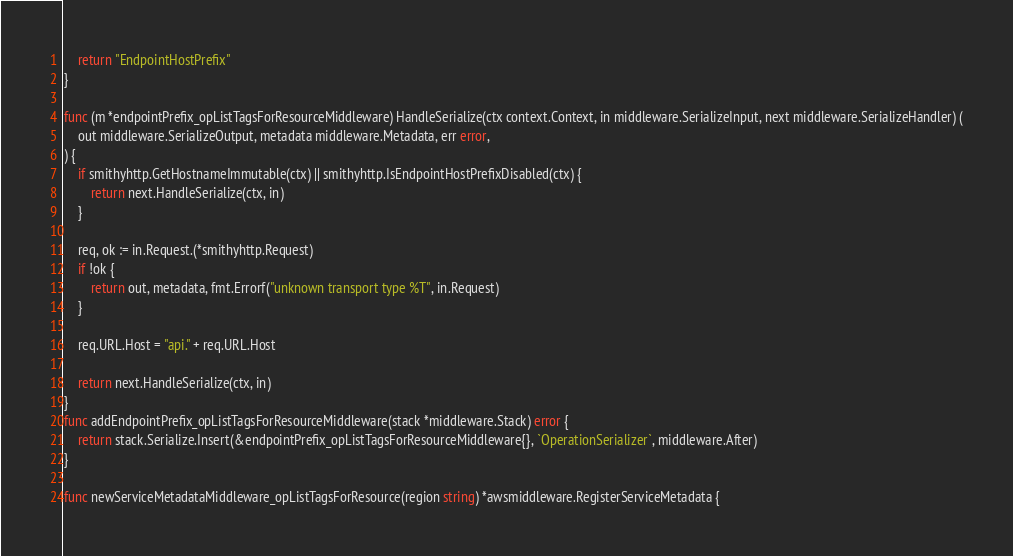<code> <loc_0><loc_0><loc_500><loc_500><_Go_>	return "EndpointHostPrefix"
}

func (m *endpointPrefix_opListTagsForResourceMiddleware) HandleSerialize(ctx context.Context, in middleware.SerializeInput, next middleware.SerializeHandler) (
	out middleware.SerializeOutput, metadata middleware.Metadata, err error,
) {
	if smithyhttp.GetHostnameImmutable(ctx) || smithyhttp.IsEndpointHostPrefixDisabled(ctx) {
		return next.HandleSerialize(ctx, in)
	}

	req, ok := in.Request.(*smithyhttp.Request)
	if !ok {
		return out, metadata, fmt.Errorf("unknown transport type %T", in.Request)
	}

	req.URL.Host = "api." + req.URL.Host

	return next.HandleSerialize(ctx, in)
}
func addEndpointPrefix_opListTagsForResourceMiddleware(stack *middleware.Stack) error {
	return stack.Serialize.Insert(&endpointPrefix_opListTagsForResourceMiddleware{}, `OperationSerializer`, middleware.After)
}

func newServiceMetadataMiddleware_opListTagsForResource(region string) *awsmiddleware.RegisterServiceMetadata {</code> 